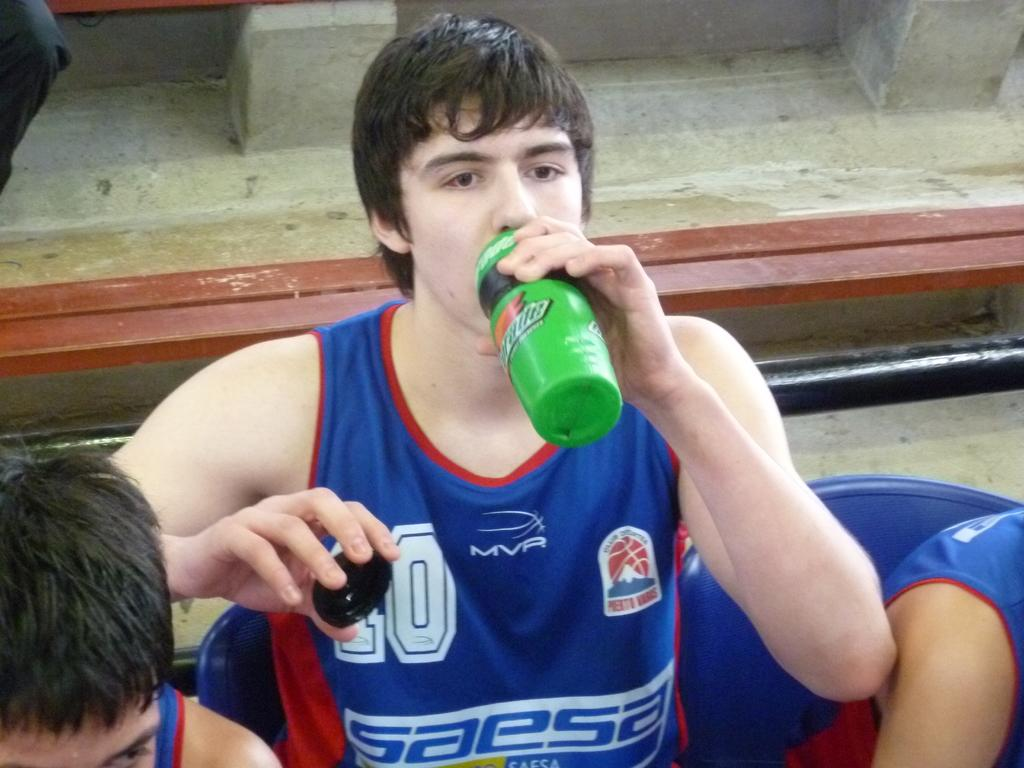Provide a one-sentence caption for the provided image. a person drinking out of a Gatorade bottle. 